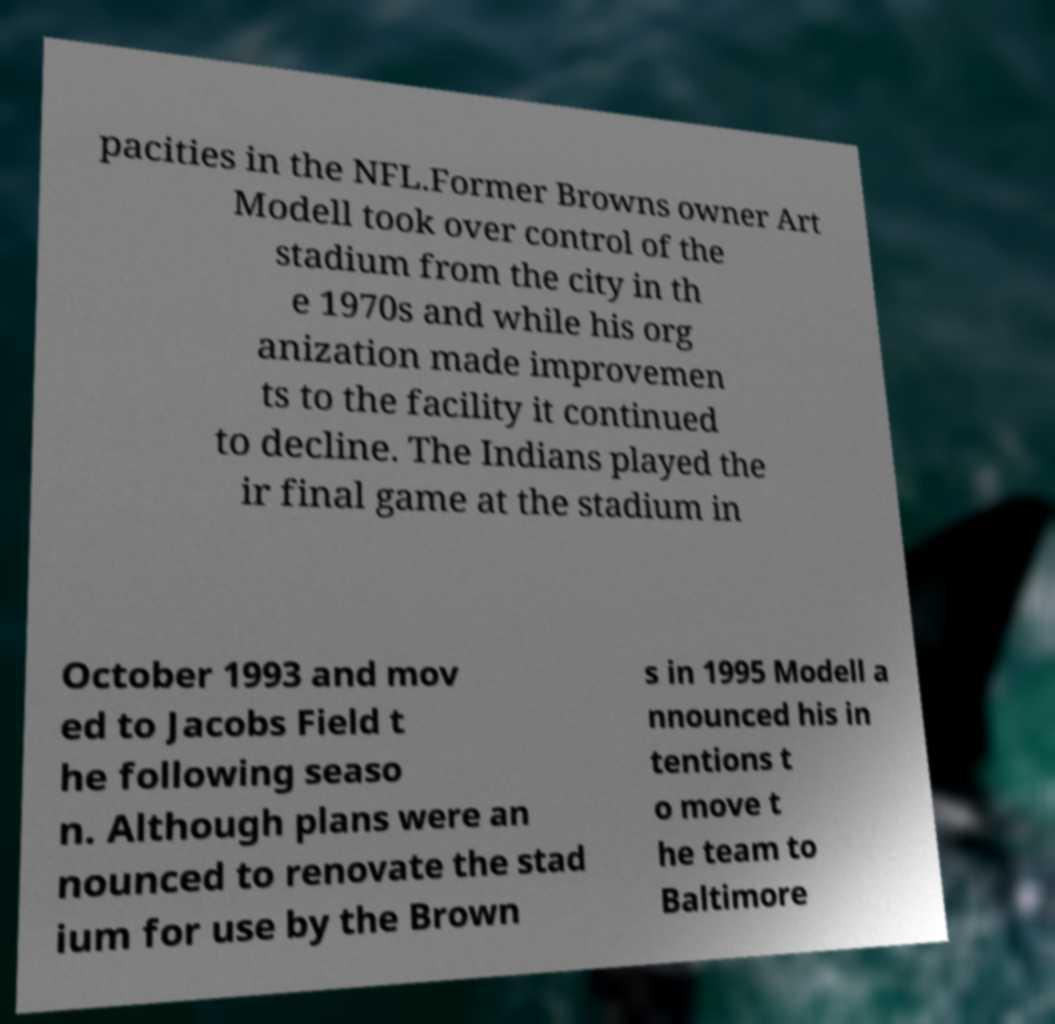What messages or text are displayed in this image? I need them in a readable, typed format. pacities in the NFL.Former Browns owner Art Modell took over control of the stadium from the city in th e 1970s and while his org anization made improvemen ts to the facility it continued to decline. The Indians played the ir final game at the stadium in October 1993 and mov ed to Jacobs Field t he following seaso n. Although plans were an nounced to renovate the stad ium for use by the Brown s in 1995 Modell a nnounced his in tentions t o move t he team to Baltimore 